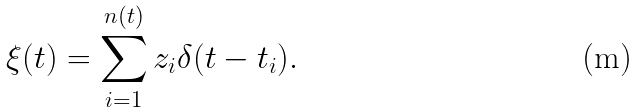<formula> <loc_0><loc_0><loc_500><loc_500>\xi ( t ) = \sum _ { i = 1 } ^ { n ( t ) } z _ { i } \delta ( t - t _ { i } ) .</formula> 